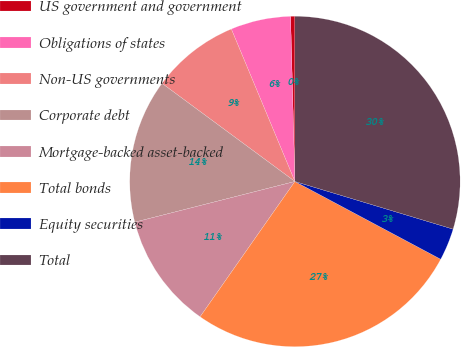Convert chart. <chart><loc_0><loc_0><loc_500><loc_500><pie_chart><fcel>US government and government<fcel>Obligations of states<fcel>Non-US governments<fcel>Corporate debt<fcel>Mortgage-backed asset-backed<fcel>Total bonds<fcel>Equity securities<fcel>Total<nl><fcel>0.42%<fcel>5.87%<fcel>8.59%<fcel>14.08%<fcel>11.31%<fcel>26.93%<fcel>3.14%<fcel>29.66%<nl></chart> 